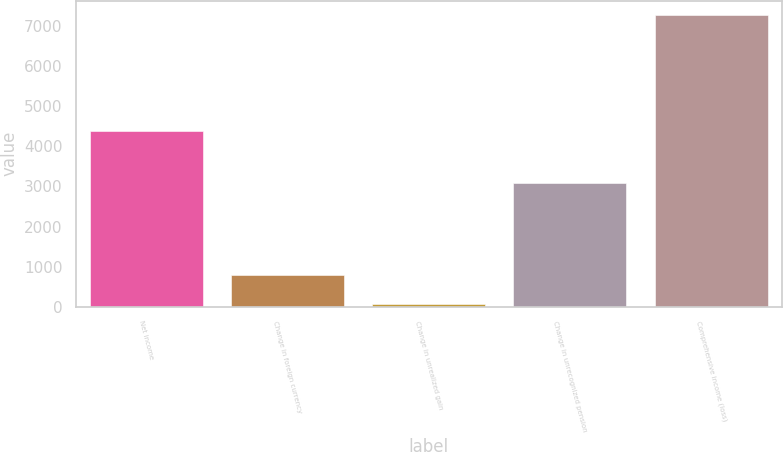Convert chart to OTSL. <chart><loc_0><loc_0><loc_500><loc_500><bar_chart><fcel>Net income<fcel>Change in foreign currency<fcel>Change in unrealized gain<fcel>Change in unrecognized pension<fcel>Comprehensive income (loss)<nl><fcel>4372<fcel>786.9<fcel>67<fcel>3094<fcel>7266<nl></chart> 